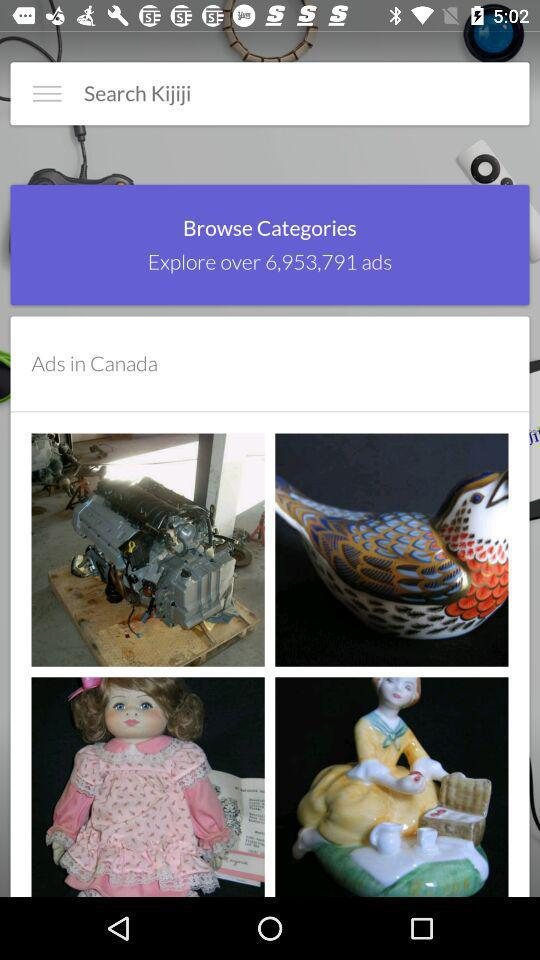How many ads in total are there to explore? There are over 6,953,791 ads to explore in total. 